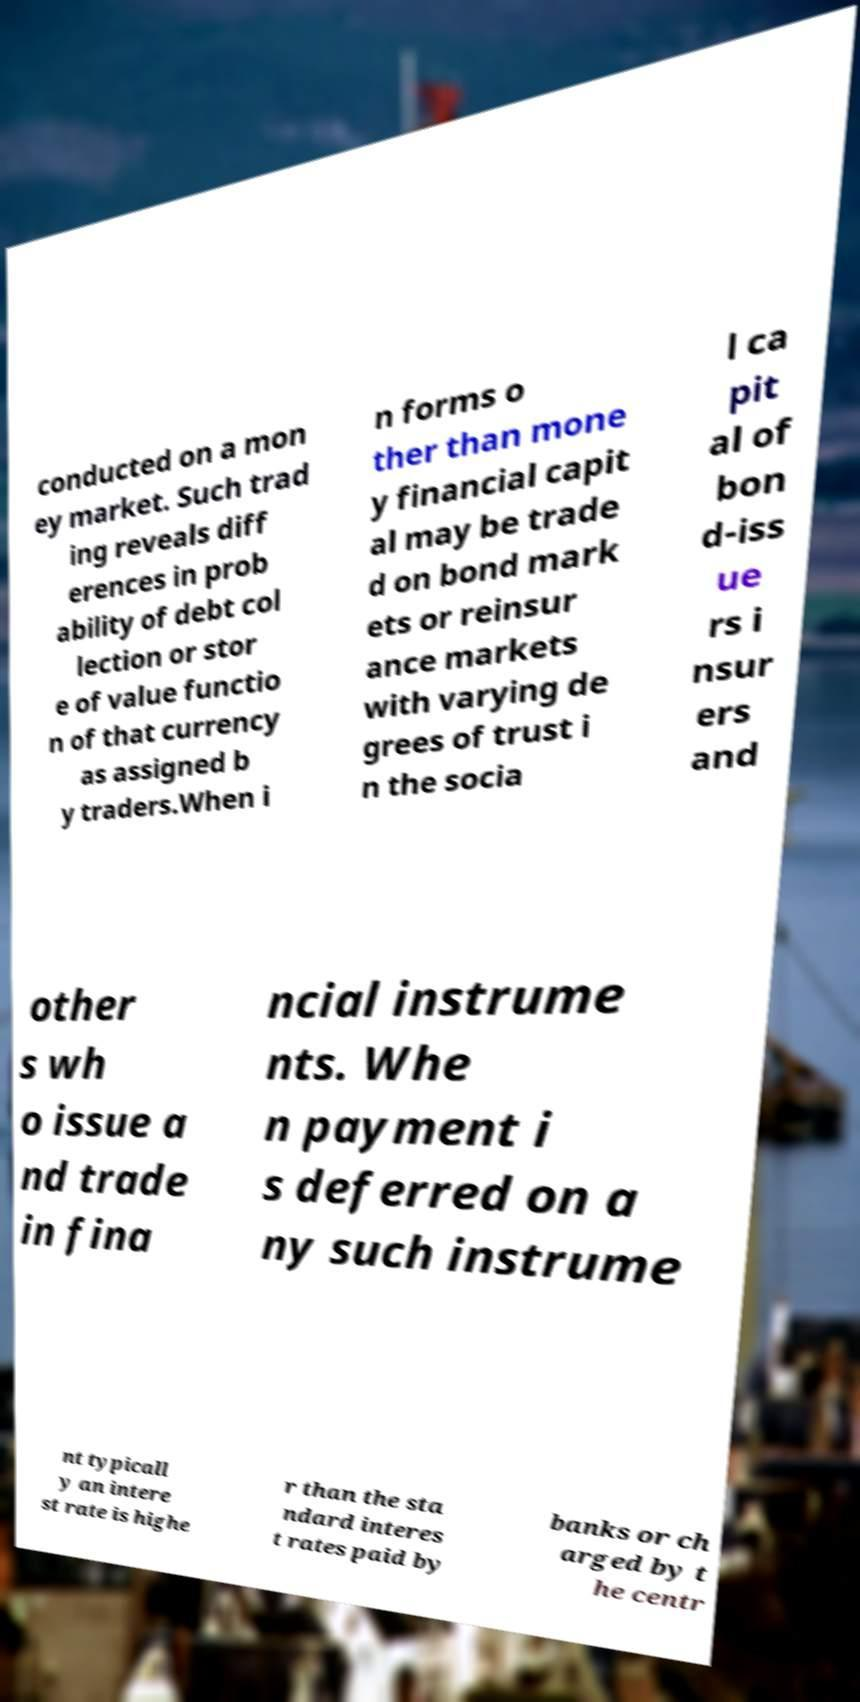Can you accurately transcribe the text from the provided image for me? conducted on a mon ey market. Such trad ing reveals diff erences in prob ability of debt col lection or stor e of value functio n of that currency as assigned b y traders.When i n forms o ther than mone y financial capit al may be trade d on bond mark ets or reinsur ance markets with varying de grees of trust i n the socia l ca pit al of bon d-iss ue rs i nsur ers and other s wh o issue a nd trade in fina ncial instrume nts. Whe n payment i s deferred on a ny such instrume nt typicall y an intere st rate is highe r than the sta ndard interes t rates paid by banks or ch arged by t he centr 